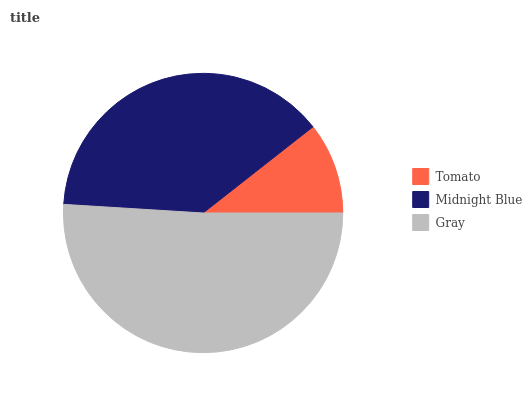Is Tomato the minimum?
Answer yes or no. Yes. Is Gray the maximum?
Answer yes or no. Yes. Is Midnight Blue the minimum?
Answer yes or no. No. Is Midnight Blue the maximum?
Answer yes or no. No. Is Midnight Blue greater than Tomato?
Answer yes or no. Yes. Is Tomato less than Midnight Blue?
Answer yes or no. Yes. Is Tomato greater than Midnight Blue?
Answer yes or no. No. Is Midnight Blue less than Tomato?
Answer yes or no. No. Is Midnight Blue the high median?
Answer yes or no. Yes. Is Midnight Blue the low median?
Answer yes or no. Yes. Is Gray the high median?
Answer yes or no. No. Is Tomato the low median?
Answer yes or no. No. 